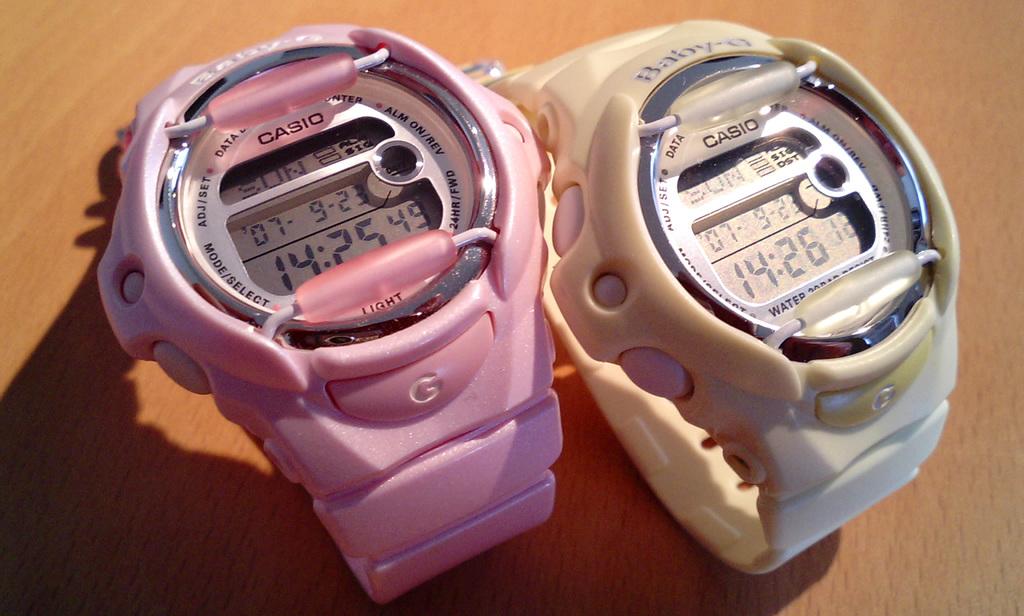What is the day of the week??
Offer a very short reply. Sunday. What time is it on the pink watch?
Your response must be concise. 14:25. 